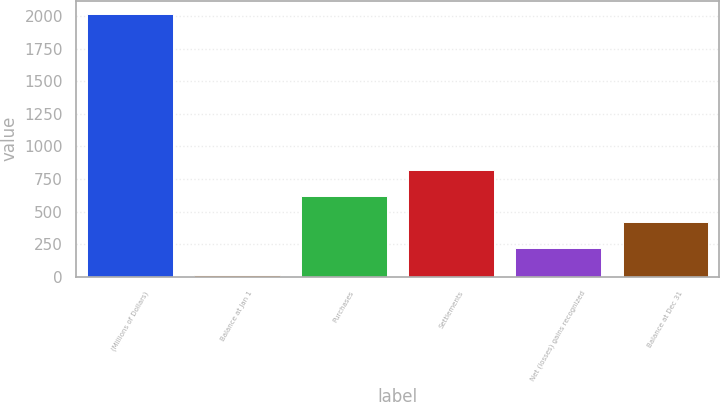Convert chart to OTSL. <chart><loc_0><loc_0><loc_500><loc_500><bar_chart><fcel>(Millions of Dollars)<fcel>Balance at Jan 1<fcel>Purchases<fcel>Settlements<fcel>Net (losses) gains recognized<fcel>Balance at Dec 31<nl><fcel>2017<fcel>17<fcel>617<fcel>817<fcel>217<fcel>417<nl></chart> 